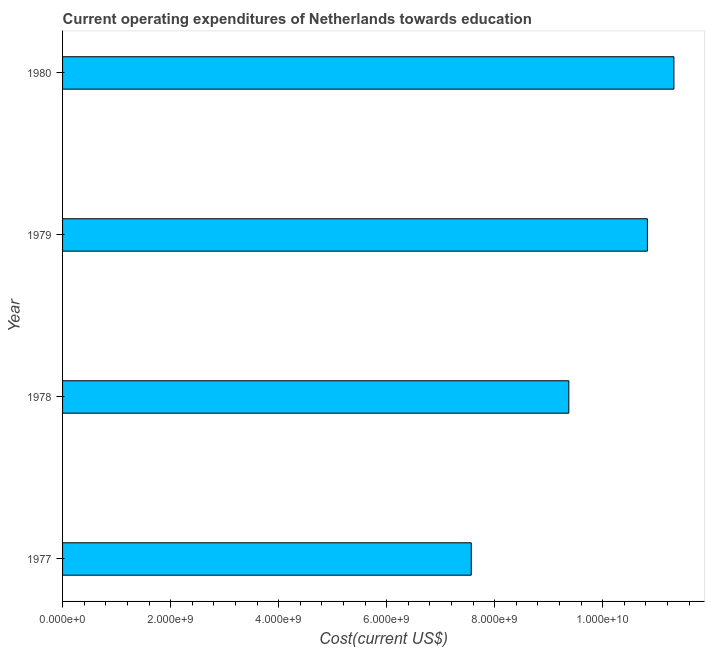Does the graph contain any zero values?
Provide a succinct answer. No. What is the title of the graph?
Make the answer very short. Current operating expenditures of Netherlands towards education. What is the label or title of the X-axis?
Offer a very short reply. Cost(current US$). What is the label or title of the Y-axis?
Offer a terse response. Year. What is the education expenditure in 1978?
Provide a short and direct response. 9.37e+09. Across all years, what is the maximum education expenditure?
Give a very brief answer. 1.13e+1. Across all years, what is the minimum education expenditure?
Give a very brief answer. 7.57e+09. What is the sum of the education expenditure?
Ensure brevity in your answer.  3.91e+1. What is the difference between the education expenditure in 1977 and 1980?
Make the answer very short. -3.75e+09. What is the average education expenditure per year?
Give a very brief answer. 9.77e+09. What is the median education expenditure?
Your response must be concise. 1.01e+1. Do a majority of the years between 1977 and 1978 (inclusive) have education expenditure greater than 4400000000 US$?
Offer a terse response. Yes. Is the difference between the education expenditure in 1978 and 1979 greater than the difference between any two years?
Provide a short and direct response. No. What is the difference between the highest and the second highest education expenditure?
Make the answer very short. 4.91e+08. Is the sum of the education expenditure in 1977 and 1978 greater than the maximum education expenditure across all years?
Your answer should be compact. Yes. What is the difference between the highest and the lowest education expenditure?
Your answer should be compact. 3.75e+09. Are all the bars in the graph horizontal?
Provide a short and direct response. Yes. What is the Cost(current US$) in 1977?
Your answer should be very brief. 7.57e+09. What is the Cost(current US$) of 1978?
Provide a succinct answer. 9.37e+09. What is the Cost(current US$) of 1979?
Keep it short and to the point. 1.08e+1. What is the Cost(current US$) in 1980?
Provide a short and direct response. 1.13e+1. What is the difference between the Cost(current US$) in 1977 and 1978?
Your answer should be very brief. -1.81e+09. What is the difference between the Cost(current US$) in 1977 and 1979?
Your answer should be compact. -3.26e+09. What is the difference between the Cost(current US$) in 1977 and 1980?
Your answer should be very brief. -3.75e+09. What is the difference between the Cost(current US$) in 1978 and 1979?
Your answer should be compact. -1.45e+09. What is the difference between the Cost(current US$) in 1978 and 1980?
Ensure brevity in your answer.  -1.95e+09. What is the difference between the Cost(current US$) in 1979 and 1980?
Provide a succinct answer. -4.91e+08. What is the ratio of the Cost(current US$) in 1977 to that in 1978?
Make the answer very short. 0.81. What is the ratio of the Cost(current US$) in 1977 to that in 1979?
Offer a very short reply. 0.7. What is the ratio of the Cost(current US$) in 1977 to that in 1980?
Give a very brief answer. 0.67. What is the ratio of the Cost(current US$) in 1978 to that in 1979?
Your response must be concise. 0.87. What is the ratio of the Cost(current US$) in 1978 to that in 1980?
Your answer should be very brief. 0.83. 